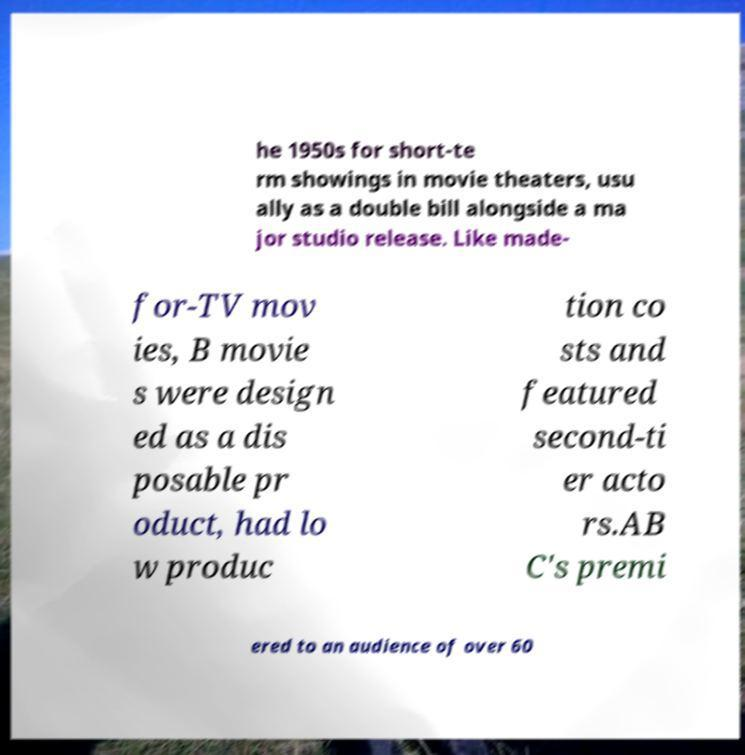For documentation purposes, I need the text within this image transcribed. Could you provide that? he 1950s for short-te rm showings in movie theaters, usu ally as a double bill alongside a ma jor studio release. Like made- for-TV mov ies, B movie s were design ed as a dis posable pr oduct, had lo w produc tion co sts and featured second-ti er acto rs.AB C's premi ered to an audience of over 60 